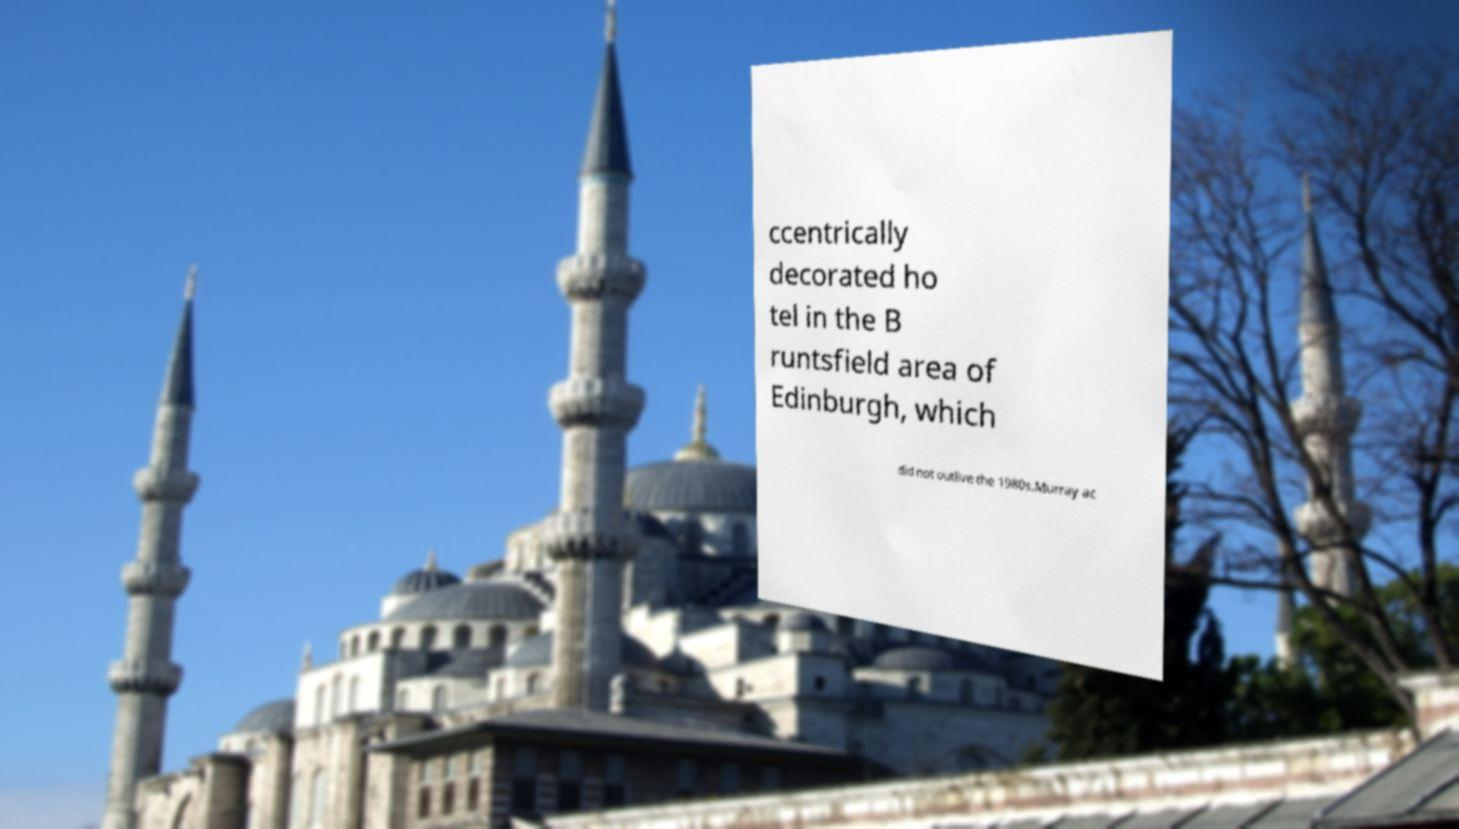Please read and relay the text visible in this image. What does it say? ccentrically decorated ho tel in the B runtsfield area of Edinburgh, which did not outlive the 1980s.Murray ac 